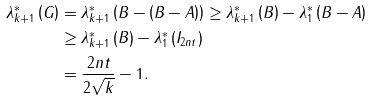Convert formula to latex. <formula><loc_0><loc_0><loc_500><loc_500>\lambda _ { k + 1 } ^ { \ast } \left ( G \right ) & = \lambda _ { k + 1 } ^ { \ast } \left ( B - \left ( B - A \right ) \right ) \geq \lambda _ { k + 1 } ^ { \ast } \left ( B \right ) - \lambda _ { 1 } ^ { \ast } \left ( B - A \right ) \\ & \geq \lambda _ { k + 1 } ^ { \ast } \left ( B \right ) - \lambda _ { 1 } ^ { \ast } \left ( I _ { 2 n t } \right ) \\ & = \frac { 2 n t } { 2 \sqrt { k } } - 1 .</formula> 